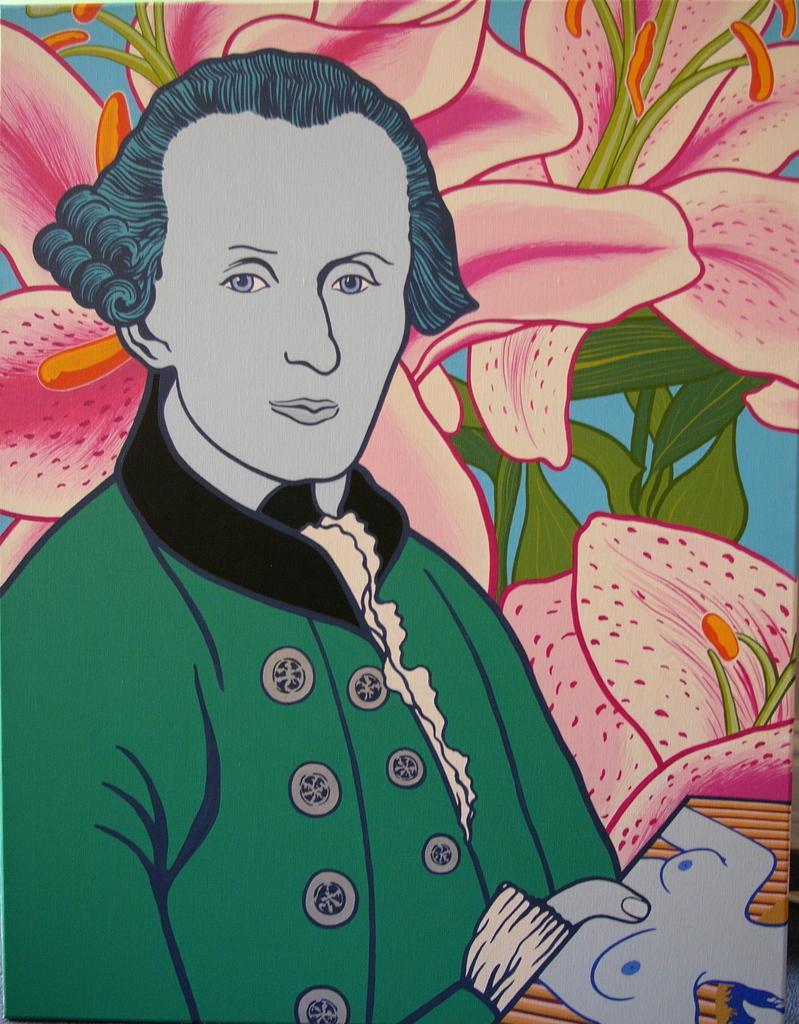Please provide a concise description of this image. In this picture I can see an art. In that art I can see a person, flowers and leaves. That person is holding a picture. Through flowers and leaves I can see the blue background.  